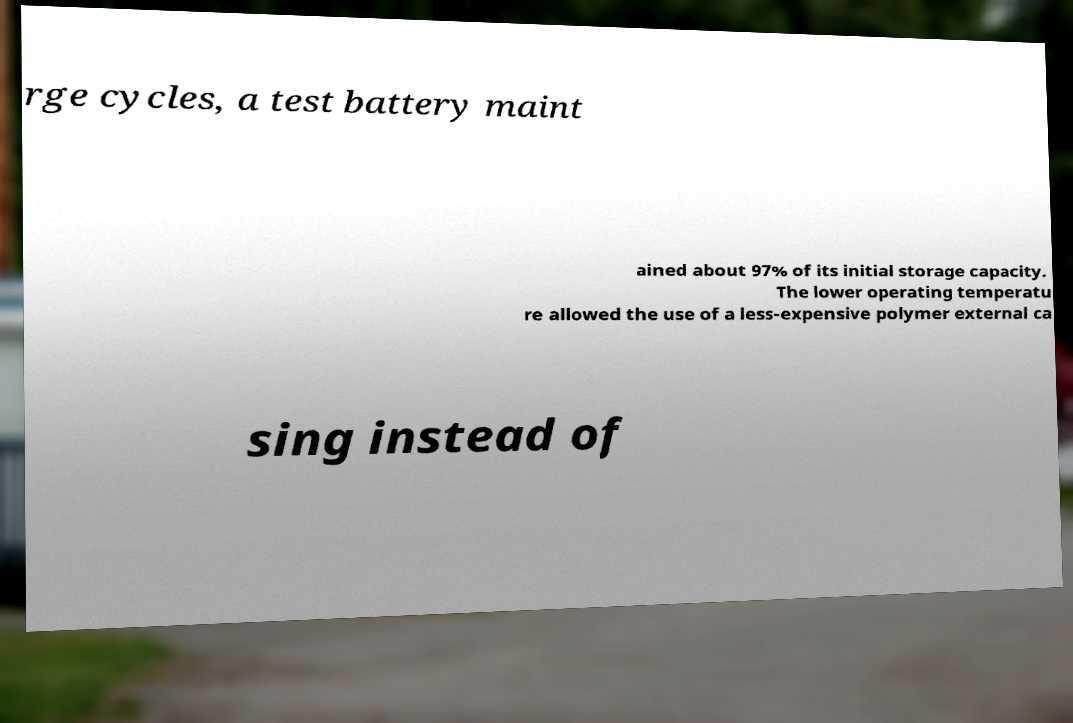Can you accurately transcribe the text from the provided image for me? rge cycles, a test battery maint ained about 97% of its initial storage capacity. The lower operating temperatu re allowed the use of a less-expensive polymer external ca sing instead of 